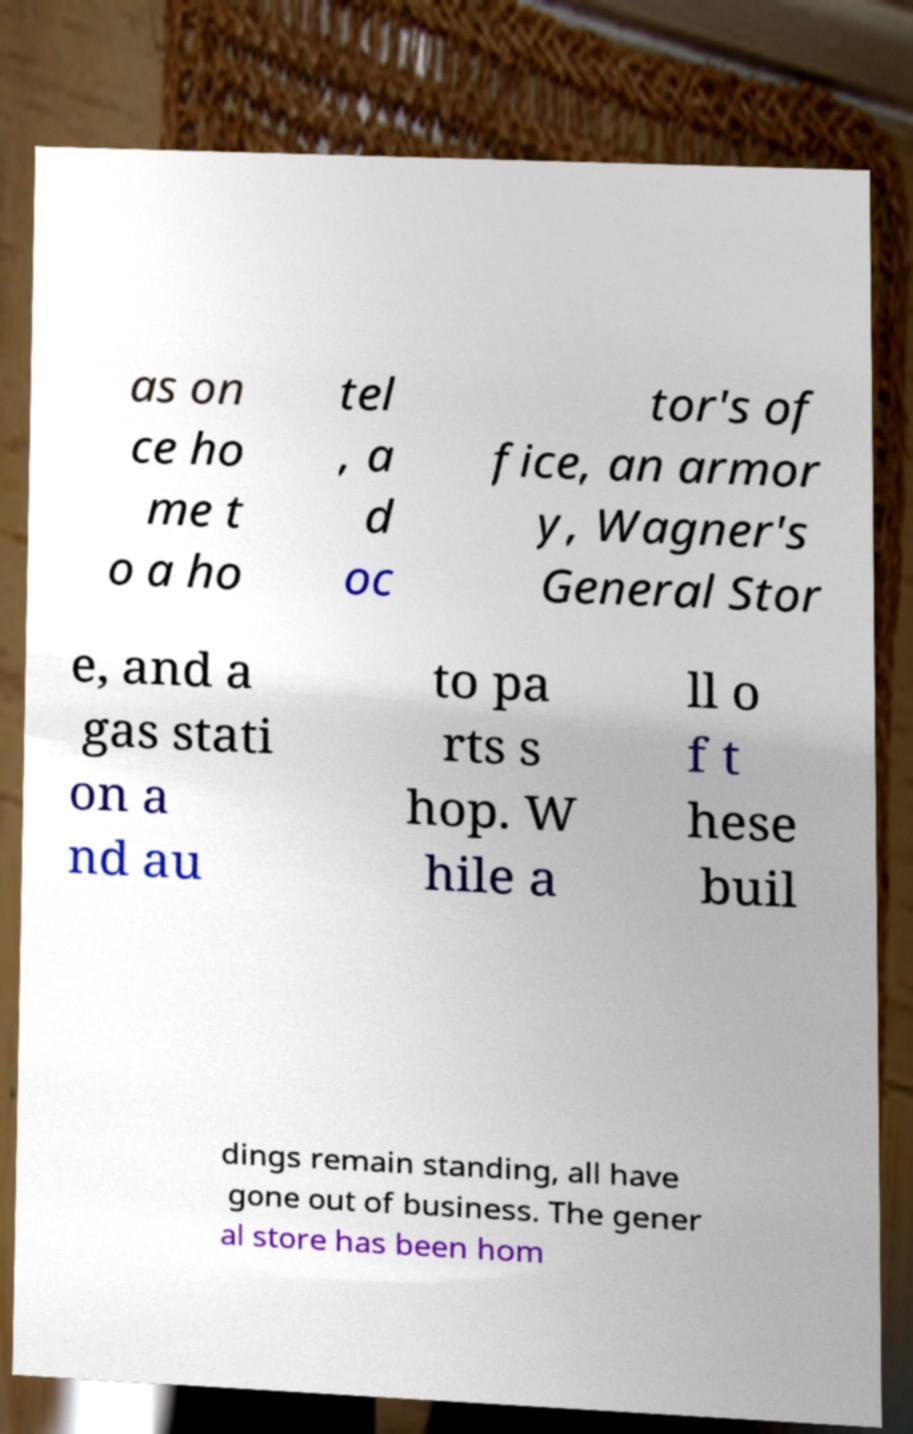For documentation purposes, I need the text within this image transcribed. Could you provide that? as on ce ho me t o a ho tel , a d oc tor's of fice, an armor y, Wagner's General Stor e, and a gas stati on a nd au to pa rts s hop. W hile a ll o f t hese buil dings remain standing, all have gone out of business. The gener al store has been hom 